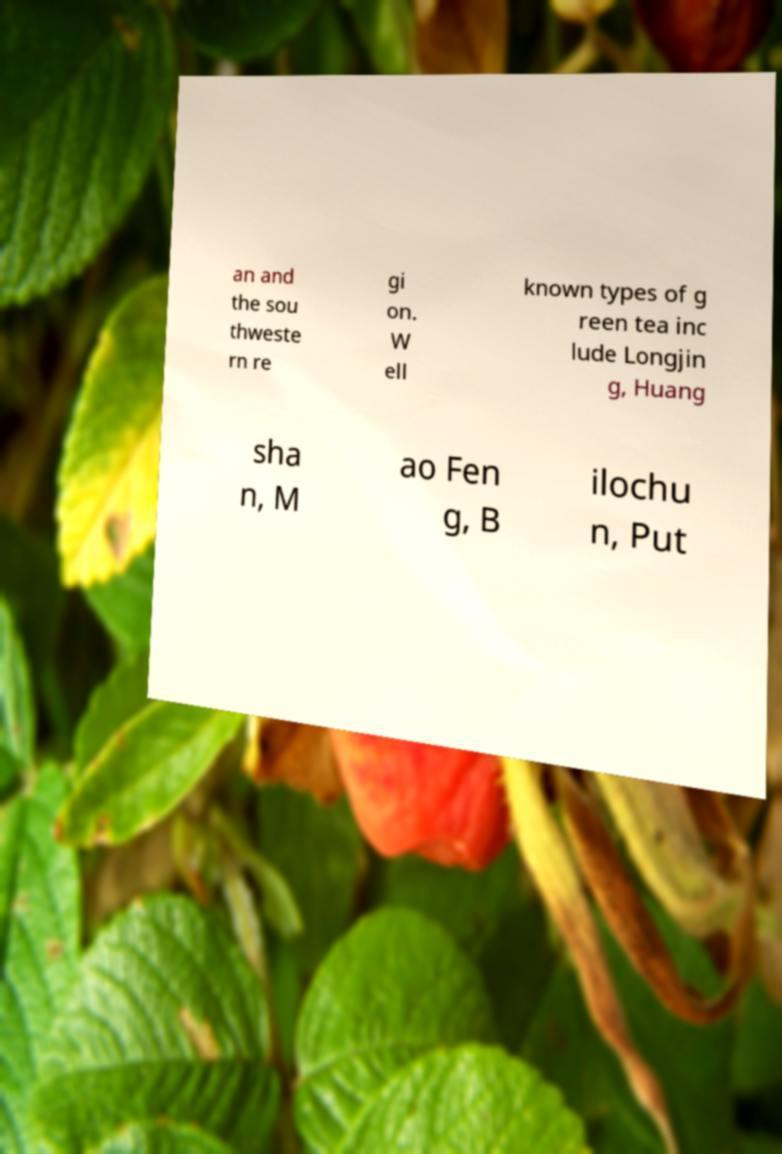Can you read and provide the text displayed in the image?This photo seems to have some interesting text. Can you extract and type it out for me? an and the sou thweste rn re gi on. W ell known types of g reen tea inc lude Longjin g, Huang sha n, M ao Fen g, B ilochu n, Put 